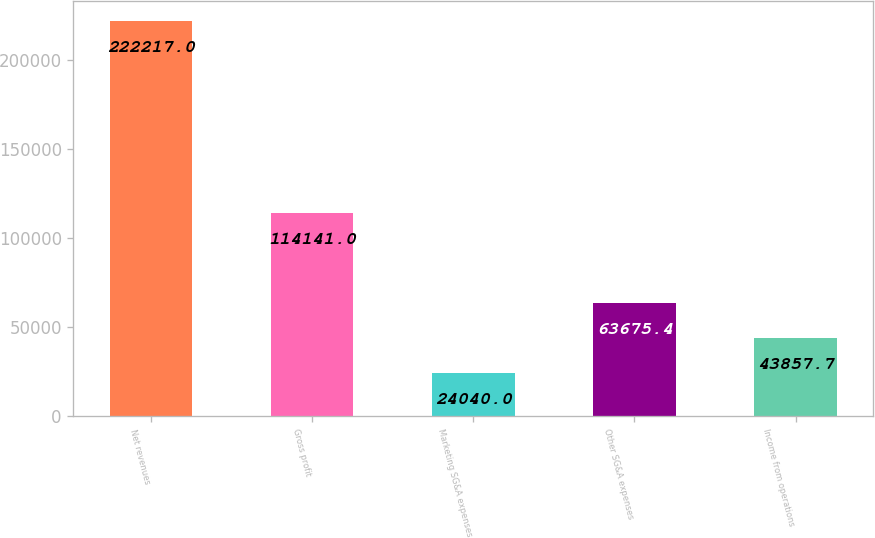<chart> <loc_0><loc_0><loc_500><loc_500><bar_chart><fcel>Net revenues<fcel>Gross profit<fcel>Marketing SG&A expenses<fcel>Other SG&A expenses<fcel>Income from operations<nl><fcel>222217<fcel>114141<fcel>24040<fcel>63675.4<fcel>43857.7<nl></chart> 